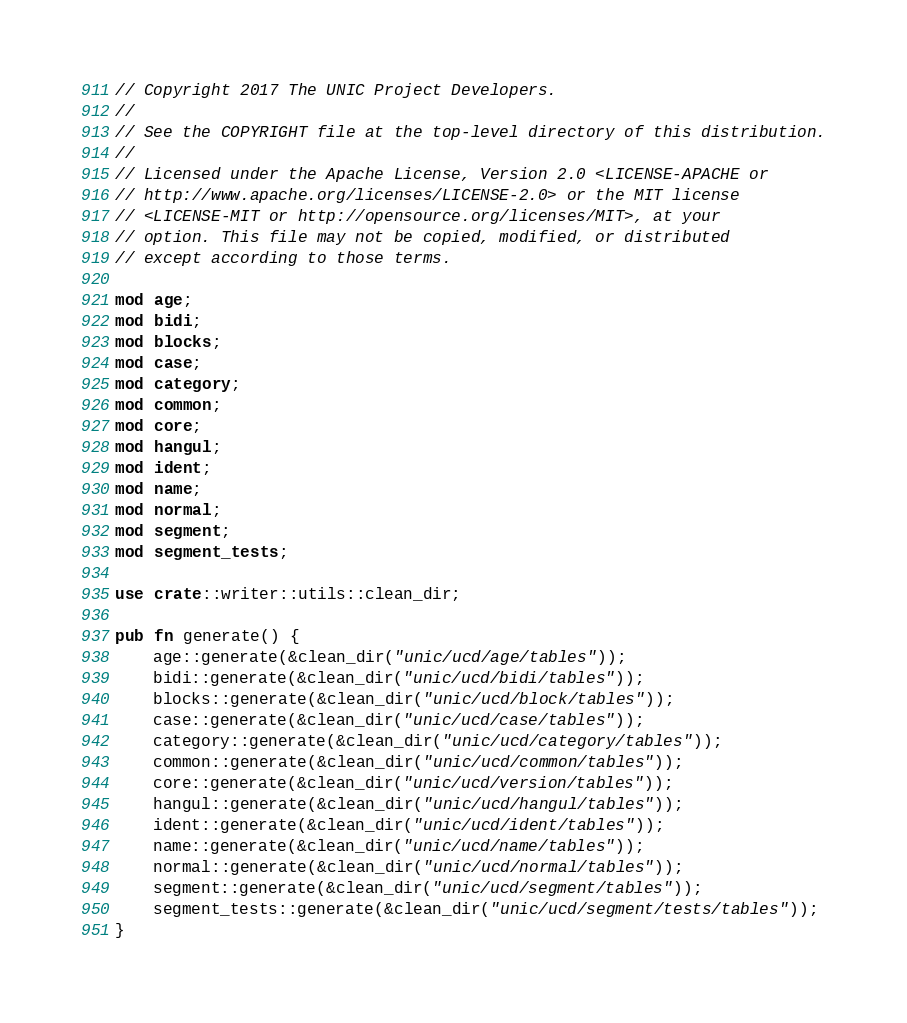Convert code to text. <code><loc_0><loc_0><loc_500><loc_500><_Rust_>// Copyright 2017 The UNIC Project Developers.
//
// See the COPYRIGHT file at the top-level directory of this distribution.
//
// Licensed under the Apache License, Version 2.0 <LICENSE-APACHE or
// http://www.apache.org/licenses/LICENSE-2.0> or the MIT license
// <LICENSE-MIT or http://opensource.org/licenses/MIT>, at your
// option. This file may not be copied, modified, or distributed
// except according to those terms.

mod age;
mod bidi;
mod blocks;
mod case;
mod category;
mod common;
mod core;
mod hangul;
mod ident;
mod name;
mod normal;
mod segment;
mod segment_tests;

use crate::writer::utils::clean_dir;

pub fn generate() {
    age::generate(&clean_dir("unic/ucd/age/tables"));
    bidi::generate(&clean_dir("unic/ucd/bidi/tables"));
    blocks::generate(&clean_dir("unic/ucd/block/tables"));
    case::generate(&clean_dir("unic/ucd/case/tables"));
    category::generate(&clean_dir("unic/ucd/category/tables"));
    common::generate(&clean_dir("unic/ucd/common/tables"));
    core::generate(&clean_dir("unic/ucd/version/tables"));
    hangul::generate(&clean_dir("unic/ucd/hangul/tables"));
    ident::generate(&clean_dir("unic/ucd/ident/tables"));
    name::generate(&clean_dir("unic/ucd/name/tables"));
    normal::generate(&clean_dir("unic/ucd/normal/tables"));
    segment::generate(&clean_dir("unic/ucd/segment/tables"));
    segment_tests::generate(&clean_dir("unic/ucd/segment/tests/tables"));
}
</code> 